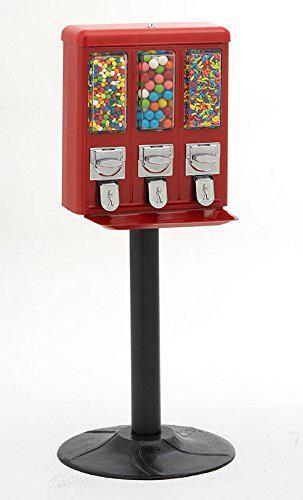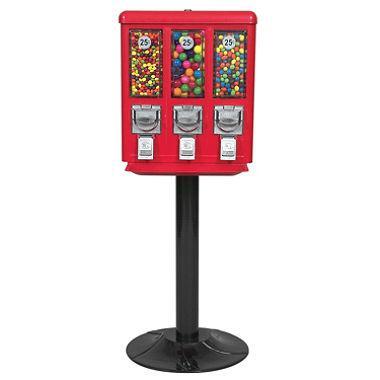The first image is the image on the left, the second image is the image on the right. For the images displayed, is the sentence "There is at least one vending machine that has three total candy compartments." factually correct? Answer yes or no. Yes. 